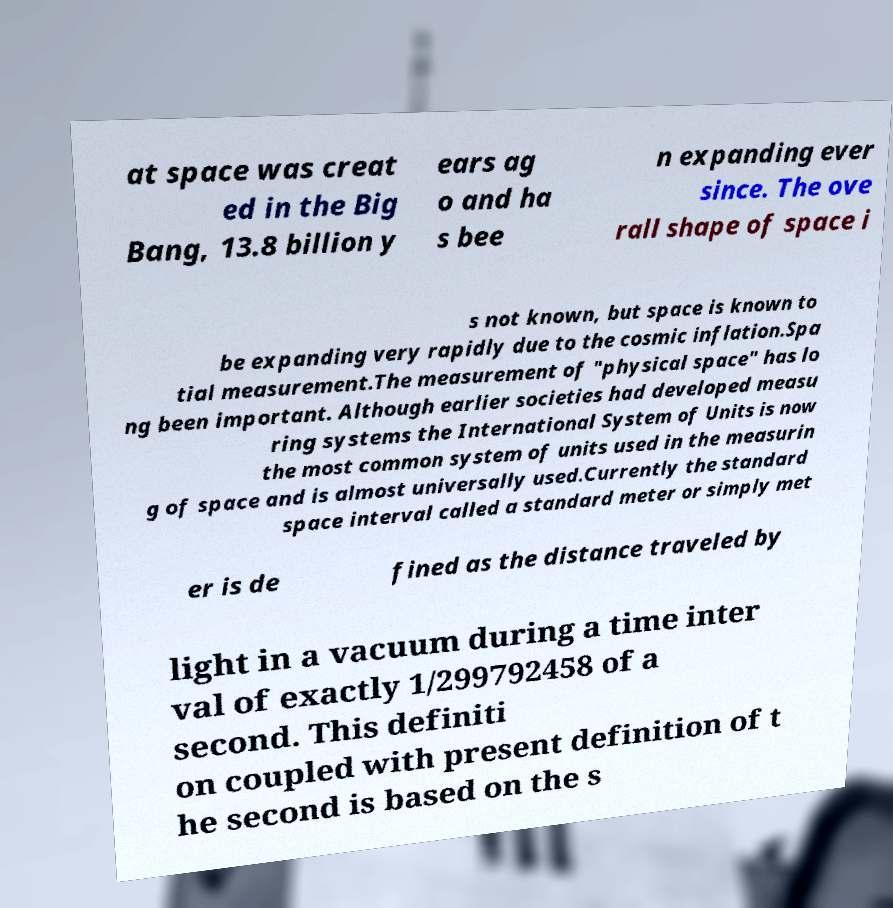Please identify and transcribe the text found in this image. at space was creat ed in the Big Bang, 13.8 billion y ears ag o and ha s bee n expanding ever since. The ove rall shape of space i s not known, but space is known to be expanding very rapidly due to the cosmic inflation.Spa tial measurement.The measurement of "physical space" has lo ng been important. Although earlier societies had developed measu ring systems the International System of Units is now the most common system of units used in the measurin g of space and is almost universally used.Currently the standard space interval called a standard meter or simply met er is de fined as the distance traveled by light in a vacuum during a time inter val of exactly 1/299792458 of a second. This definiti on coupled with present definition of t he second is based on the s 